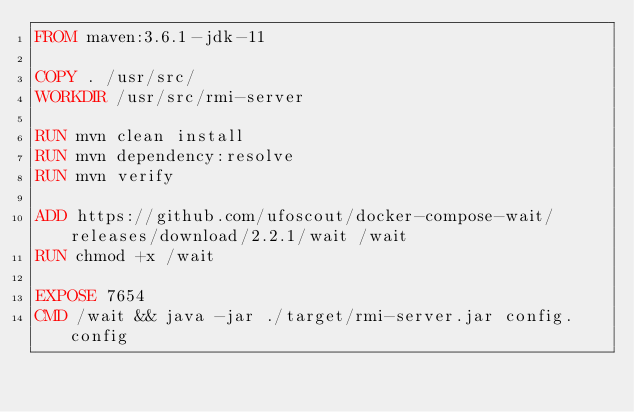<code> <loc_0><loc_0><loc_500><loc_500><_Dockerfile_>FROM maven:3.6.1-jdk-11

COPY . /usr/src/
WORKDIR /usr/src/rmi-server

RUN mvn clean install
RUN mvn dependency:resolve
RUN mvn verify

ADD https://github.com/ufoscout/docker-compose-wait/releases/download/2.2.1/wait /wait
RUN chmod +x /wait

EXPOSE 7654
CMD /wait && java -jar ./target/rmi-server.jar config.config
</code> 